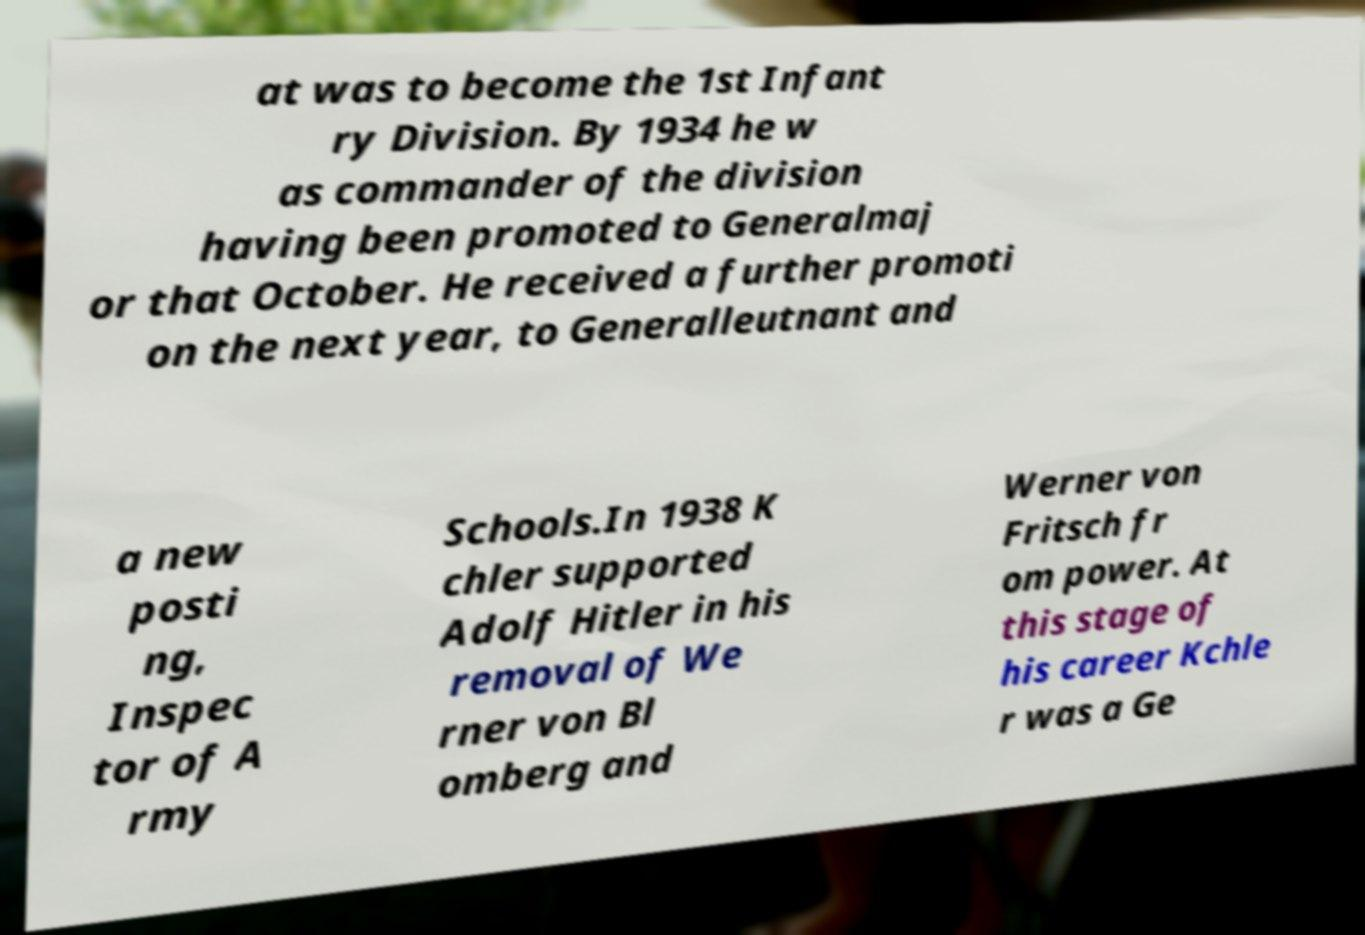Please read and relay the text visible in this image. What does it say? at was to become the 1st Infant ry Division. By 1934 he w as commander of the division having been promoted to Generalmaj or that October. He received a further promoti on the next year, to Generalleutnant and a new posti ng, Inspec tor of A rmy Schools.In 1938 K chler supported Adolf Hitler in his removal of We rner von Bl omberg and Werner von Fritsch fr om power. At this stage of his career Kchle r was a Ge 